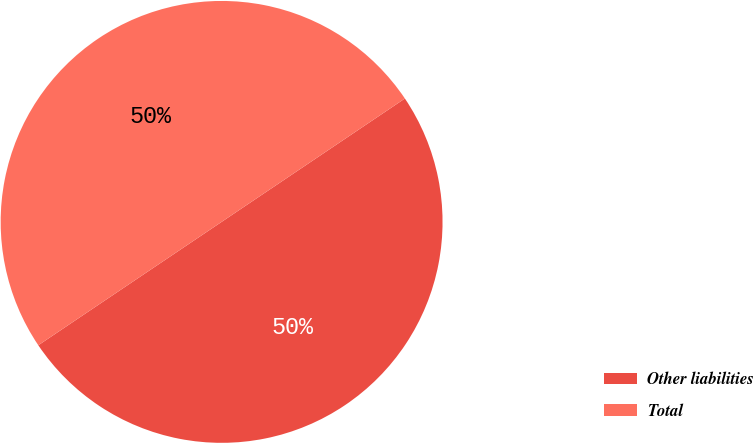<chart> <loc_0><loc_0><loc_500><loc_500><pie_chart><fcel>Other liabilities<fcel>Total<nl><fcel>50.0%<fcel>50.0%<nl></chart> 